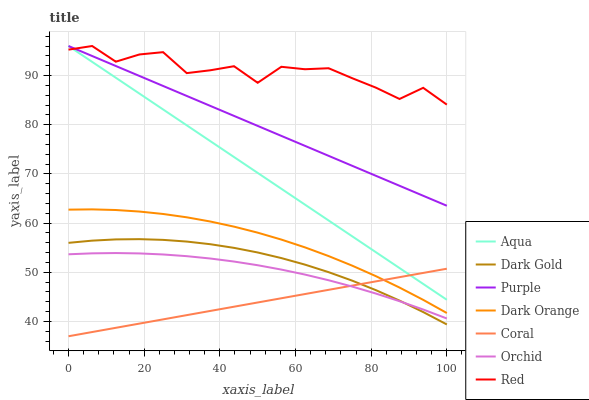Does Coral have the minimum area under the curve?
Answer yes or no. Yes. Does Red have the maximum area under the curve?
Answer yes or no. Yes. Does Dark Gold have the minimum area under the curve?
Answer yes or no. No. Does Dark Gold have the maximum area under the curve?
Answer yes or no. No. Is Coral the smoothest?
Answer yes or no. Yes. Is Red the roughest?
Answer yes or no. Yes. Is Dark Gold the smoothest?
Answer yes or no. No. Is Dark Gold the roughest?
Answer yes or no. No. Does Coral have the lowest value?
Answer yes or no. Yes. Does Dark Gold have the lowest value?
Answer yes or no. No. Does Red have the highest value?
Answer yes or no. Yes. Does Dark Gold have the highest value?
Answer yes or no. No. Is Dark Orange less than Red?
Answer yes or no. Yes. Is Red greater than Orchid?
Answer yes or no. Yes. Does Coral intersect Aqua?
Answer yes or no. Yes. Is Coral less than Aqua?
Answer yes or no. No. Is Coral greater than Aqua?
Answer yes or no. No. Does Dark Orange intersect Red?
Answer yes or no. No. 